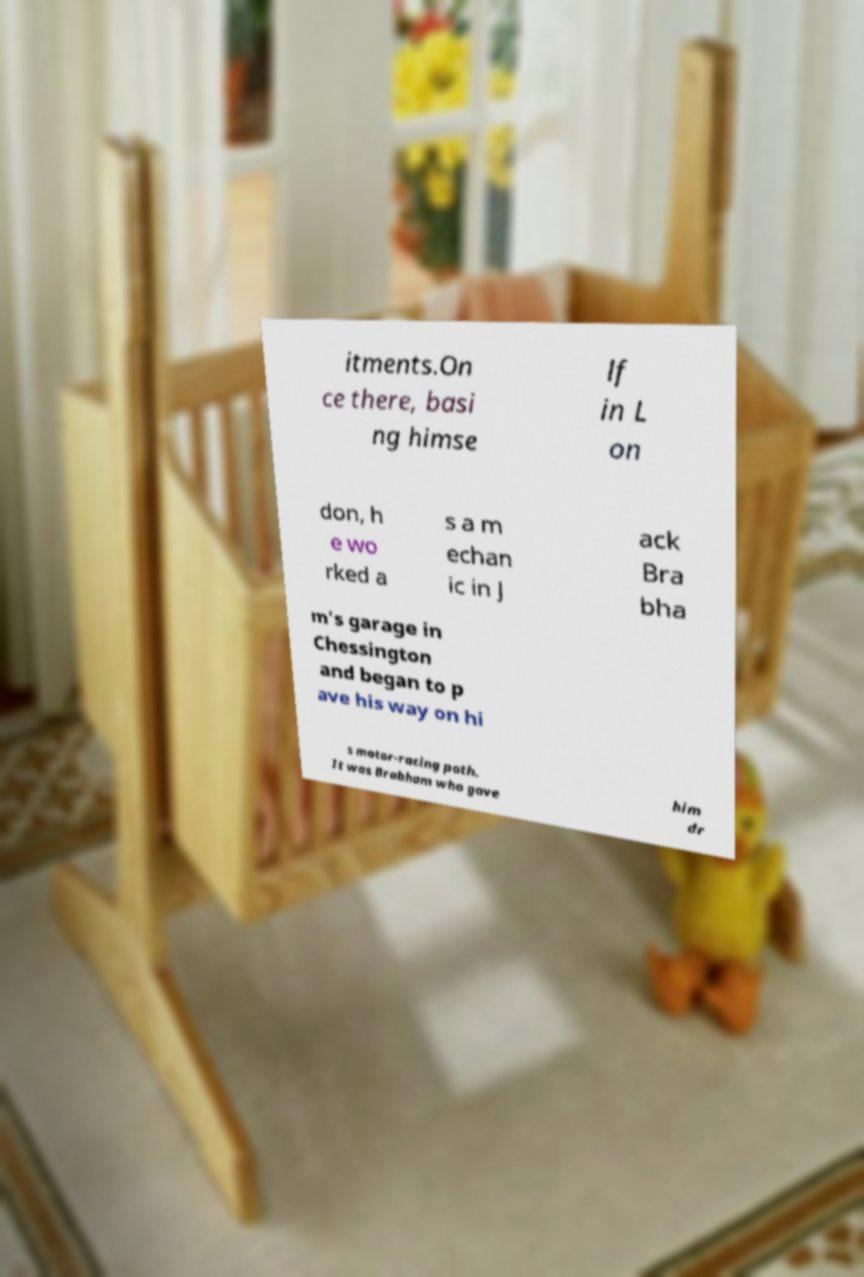I need the written content from this picture converted into text. Can you do that? itments.On ce there, basi ng himse lf in L on don, h e wo rked a s a m echan ic in J ack Bra bha m's garage in Chessington and began to p ave his way on hi s motor-racing path. It was Brabham who gave him dr 